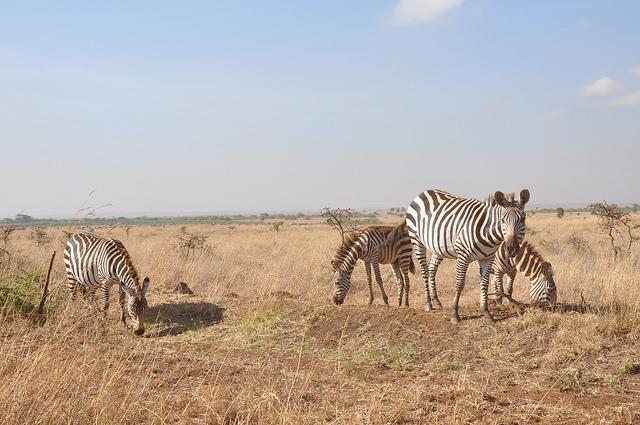Are there any baby animals?
Concise answer only. Yes. Is there a mountain in the picture?
Write a very short answer. No. How many zebra have a shadow?
Give a very brief answer. 2. How many zebra are standing in this field?
Quick response, please. 4. How many zebras are standing together?
Keep it brief. 3. What type of animals are they?
Write a very short answer. Zebras. Is this a family of zebra?
Answer briefly. Yes. 